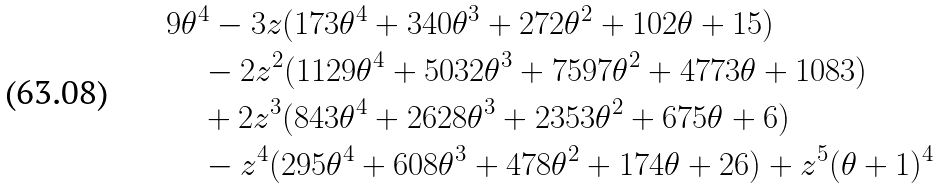Convert formula to latex. <formula><loc_0><loc_0><loc_500><loc_500>& 9 \theta ^ { 4 } - 3 z ( 1 7 3 \theta ^ { 4 } + 3 4 0 \theta ^ { 3 } + 2 7 2 \theta ^ { 2 } + 1 0 2 \theta + 1 5 ) \\ & \quad - 2 z ^ { 2 } ( 1 1 2 9 \theta ^ { 4 } + 5 0 3 2 \theta ^ { 3 } + 7 5 9 7 \theta ^ { 2 } + 4 7 7 3 \theta + 1 0 8 3 ) \\ & \quad + 2 z ^ { 3 } ( 8 4 3 \theta ^ { 4 } + 2 6 2 8 \theta ^ { 3 } + 2 3 5 3 \theta ^ { 2 } + 6 7 5 \theta + 6 ) \\ & \quad - z ^ { 4 } ( 2 9 5 \theta ^ { 4 } + 6 0 8 \theta ^ { 3 } + 4 7 8 \theta ^ { 2 } + 1 7 4 \theta + 2 6 ) + z ^ { 5 } ( \theta + 1 ) ^ { 4 }</formula> 